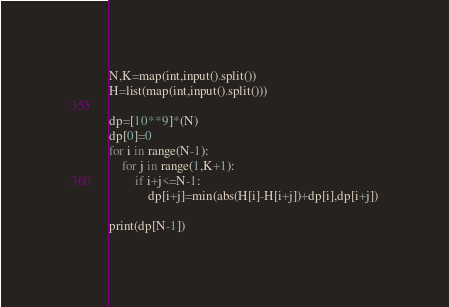<code> <loc_0><loc_0><loc_500><loc_500><_Python_>N,K=map(int,input().split())
H=list(map(int,input().split()))

dp=[10**9]*(N)
dp[0]=0
for i in range(N-1):
    for j in range(1,K+1):
        if i+j<=N-1:
            dp[i+j]=min(abs(H[i]-H[i+j])+dp[i],dp[i+j])

print(dp[N-1])</code> 